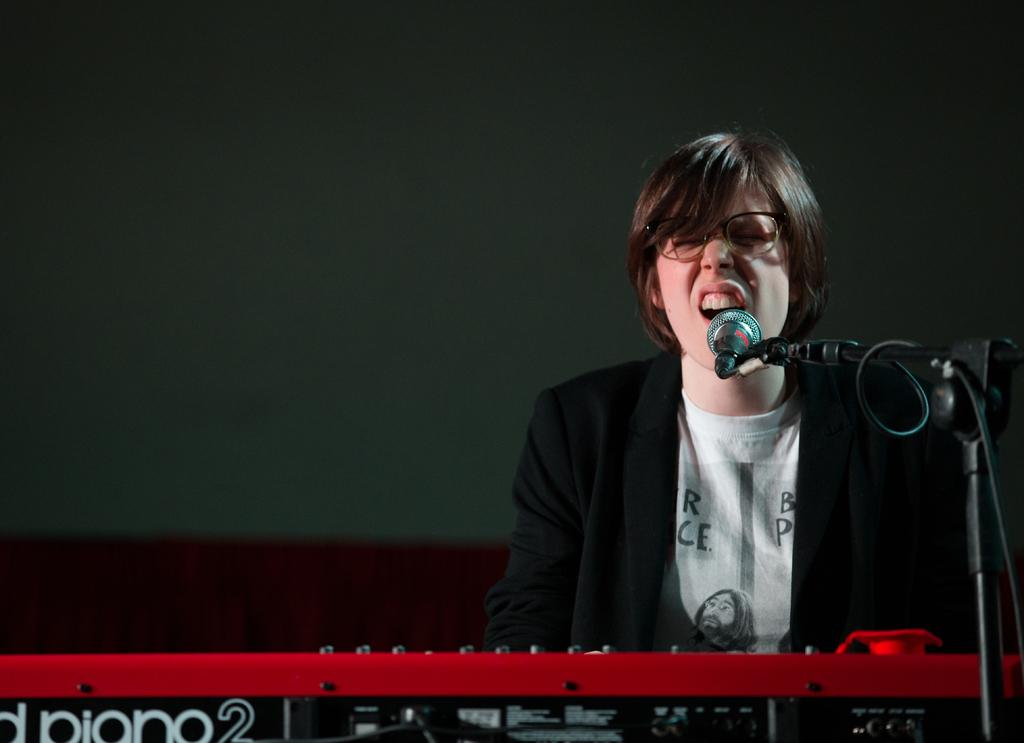Who is the main subject in the image? There is a lady in the image. What is the lady doing in the image? The lady is sitting in front of a piano. What other object is present in the image? There is a mic with a stand in the image. How many books can be seen on the piano in the image? There are no books visible on the piano in the image. 